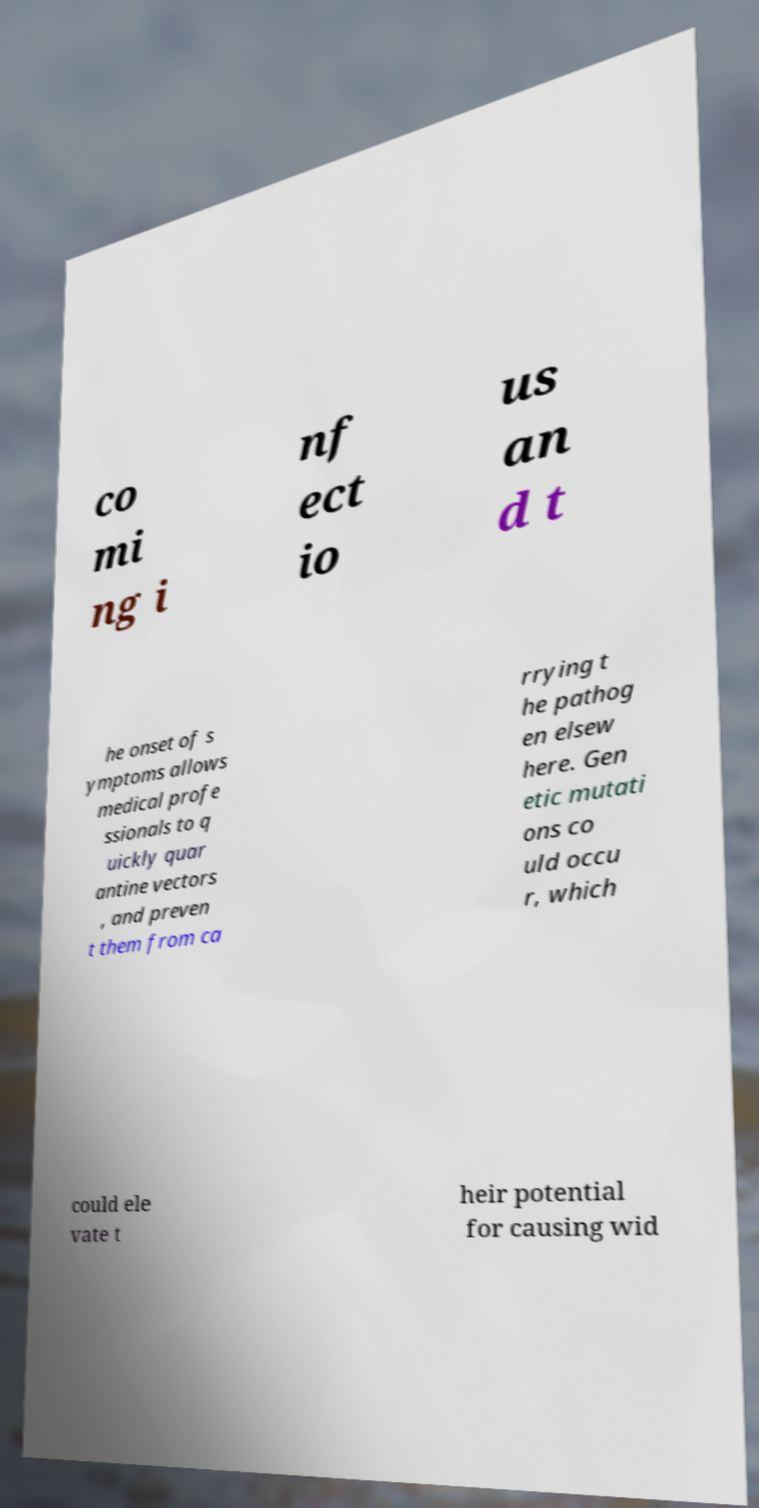There's text embedded in this image that I need extracted. Can you transcribe it verbatim? co mi ng i nf ect io us an d t he onset of s ymptoms allows medical profe ssionals to q uickly quar antine vectors , and preven t them from ca rrying t he pathog en elsew here. Gen etic mutati ons co uld occu r, which could ele vate t heir potential for causing wid 